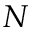<formula> <loc_0><loc_0><loc_500><loc_500>N</formula> 